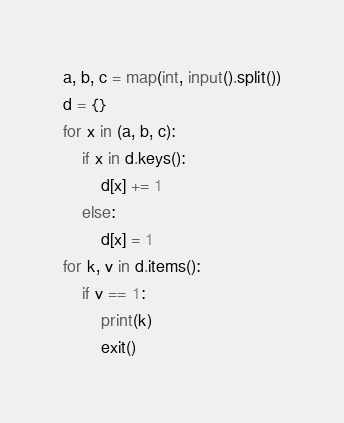<code> <loc_0><loc_0><loc_500><loc_500><_Python_>a, b, c = map(int, input().split())
d = {}
for x in (a, b, c):
    if x in d.keys():
        d[x] += 1
    else:
        d[x] = 1
for k, v in d.items():
    if v == 1:
        print(k)
        exit()</code> 